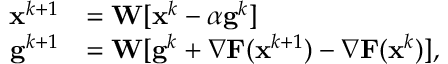Convert formula to latex. <formula><loc_0><loc_0><loc_500><loc_500>\begin{array} { r l } { { x } ^ { k + 1 } } & { = { W } [ { x } ^ { k } - \alpha { g } ^ { k } ] } \\ { { g } ^ { k + 1 } } & { = { W } [ { g } ^ { k } + { \nabla } F ( x ^ { k + 1 } ) - { \nabla } F ( x ^ { k } ) ] , } \end{array}</formula> 